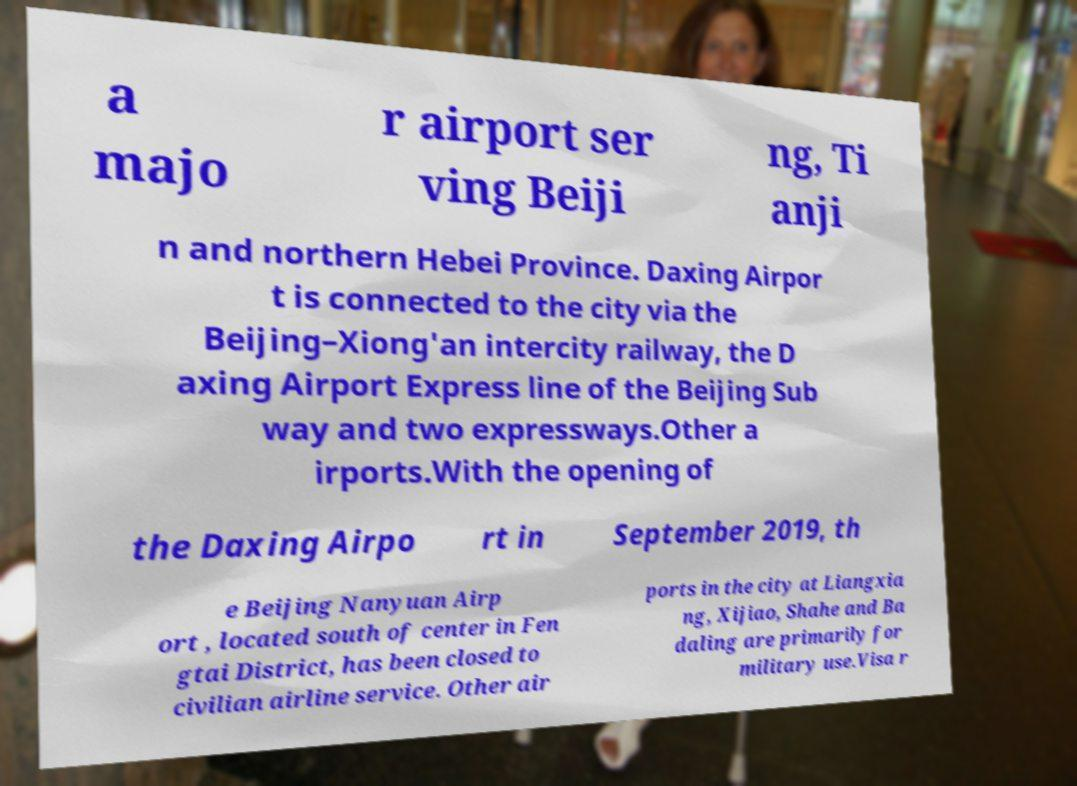Could you assist in decoding the text presented in this image and type it out clearly? a majo r airport ser ving Beiji ng, Ti anji n and northern Hebei Province. Daxing Airpor t is connected to the city via the Beijing–Xiong'an intercity railway, the D axing Airport Express line of the Beijing Sub way and two expressways.Other a irports.With the opening of the Daxing Airpo rt in September 2019, th e Beijing Nanyuan Airp ort , located south of center in Fen gtai District, has been closed to civilian airline service. Other air ports in the city at Liangxia ng, Xijiao, Shahe and Ba daling are primarily for military use.Visa r 